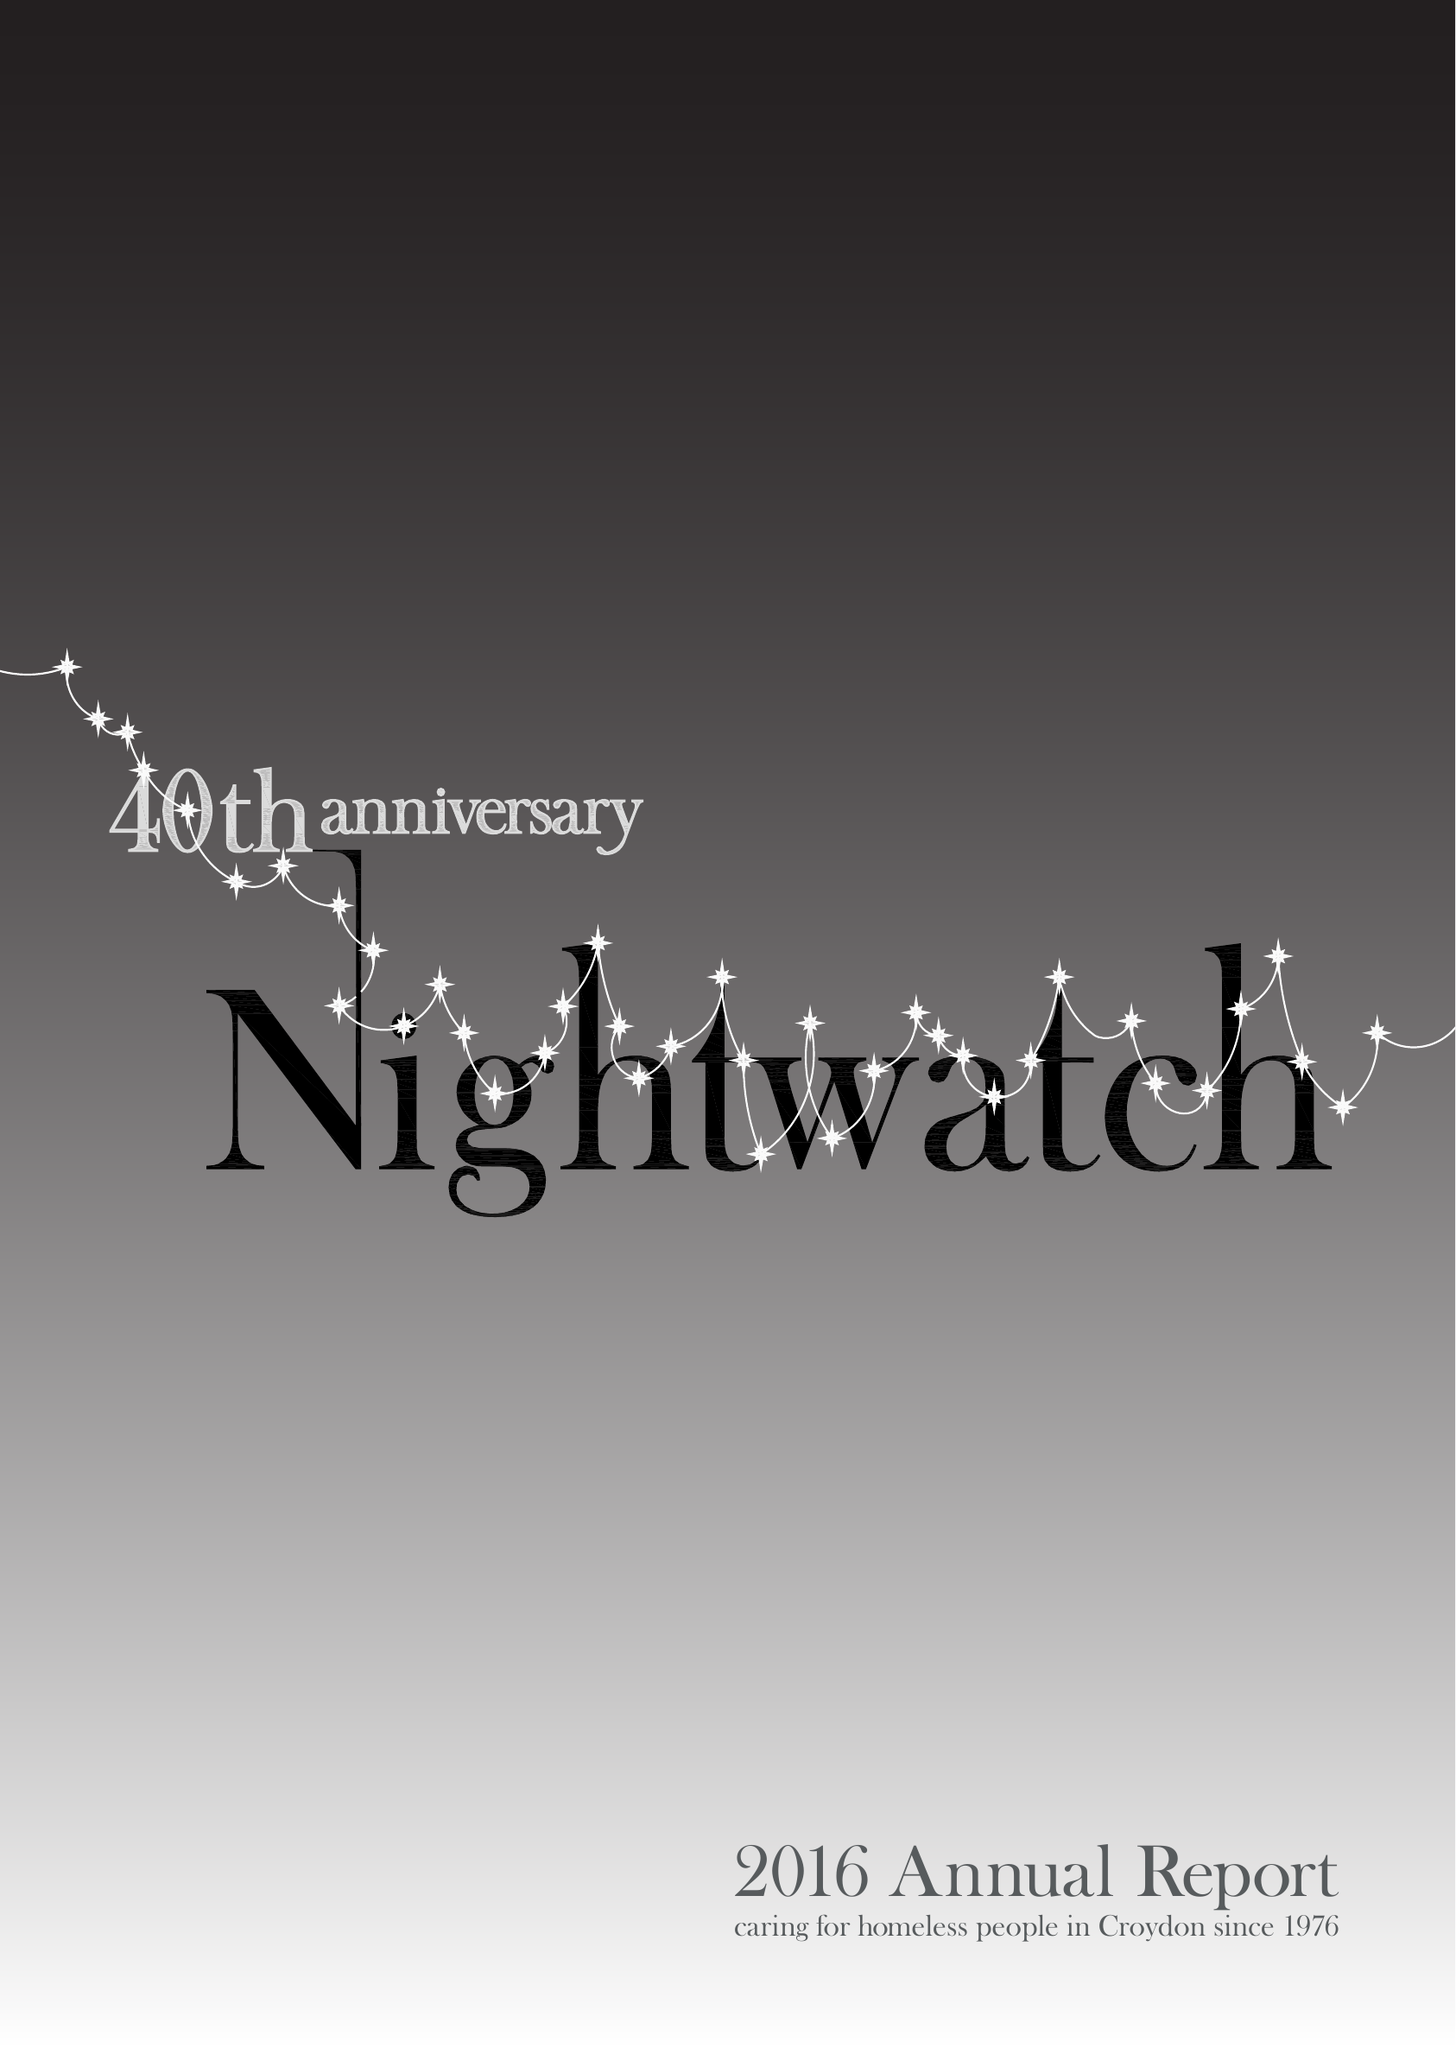What is the value for the report_date?
Answer the question using a single word or phrase. 2015-12-31 